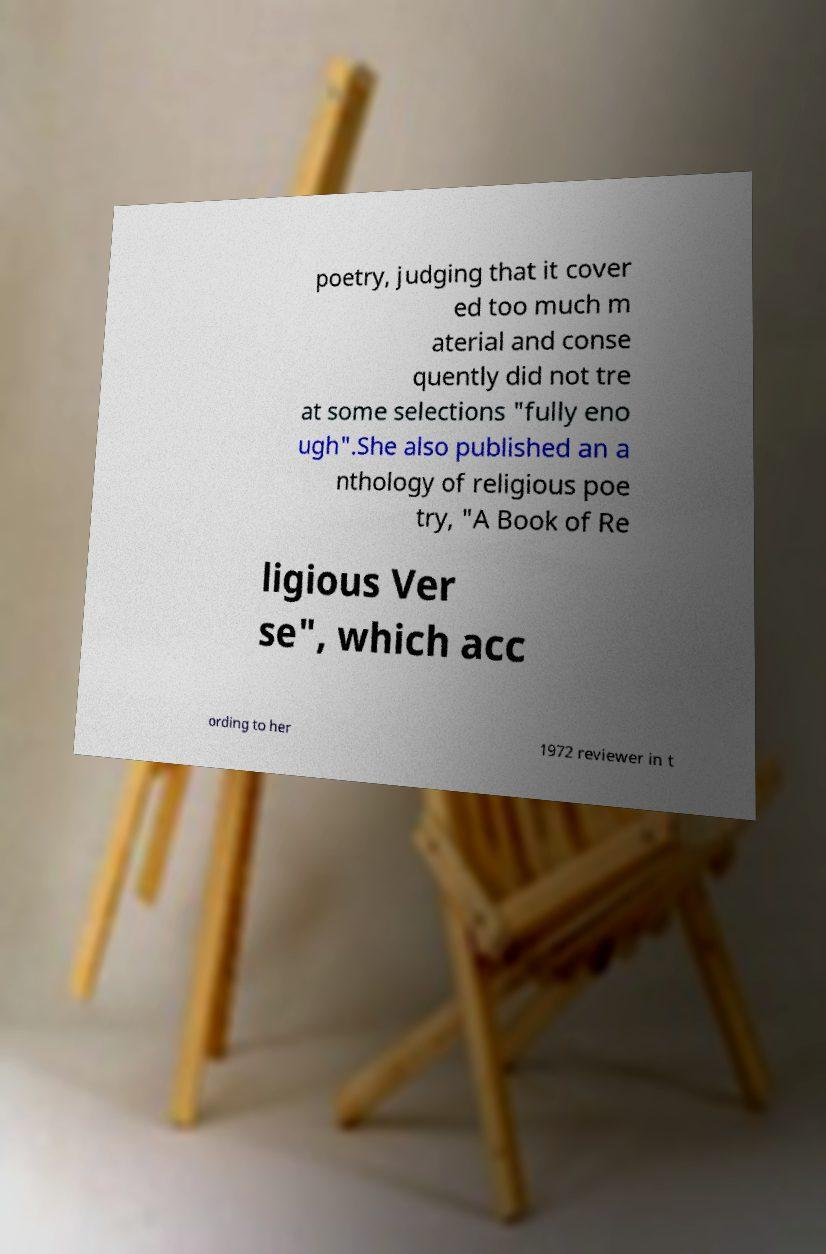Could you assist in decoding the text presented in this image and type it out clearly? poetry, judging that it cover ed too much m aterial and conse quently did not tre at some selections "fully eno ugh".She also published an a nthology of religious poe try, "A Book of Re ligious Ver se", which acc ording to her 1972 reviewer in t 